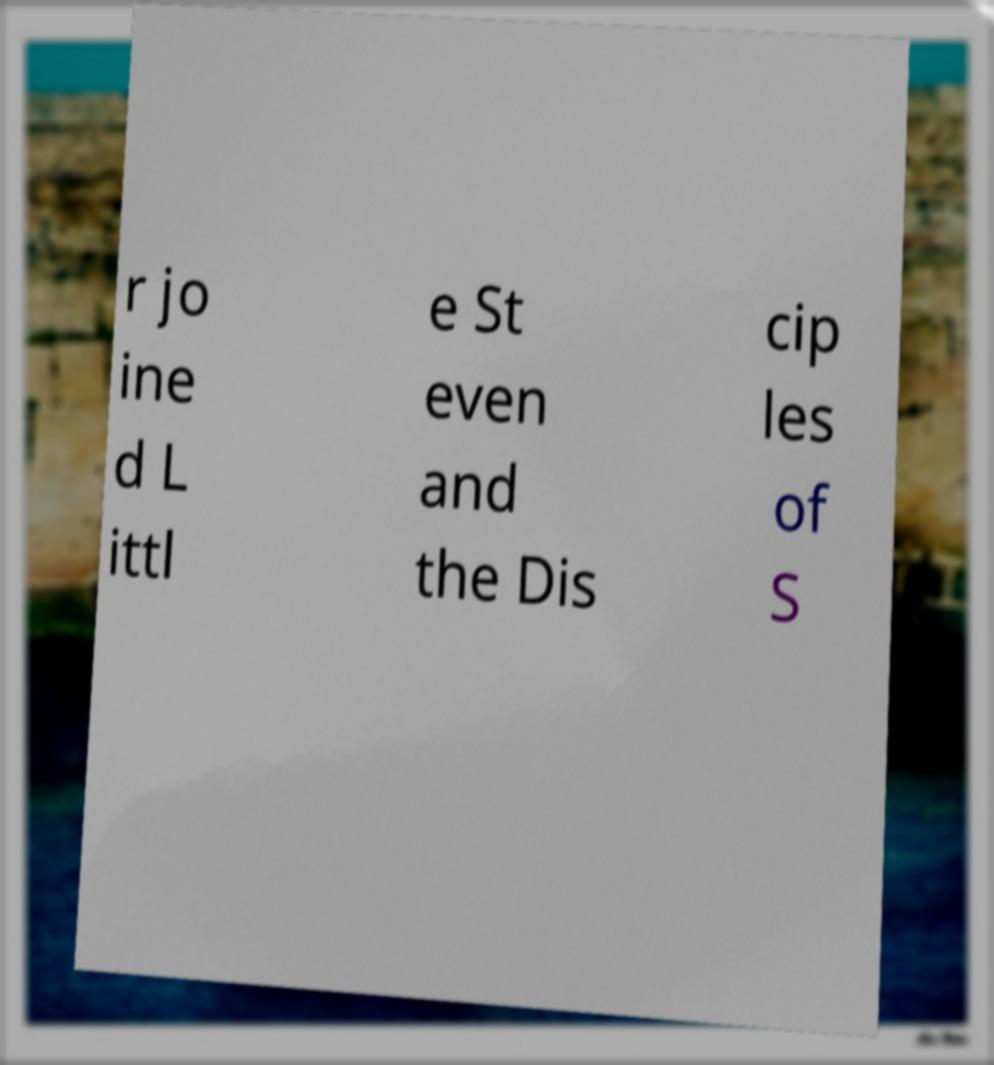What messages or text are displayed in this image? I need them in a readable, typed format. r jo ine d L ittl e St even and the Dis cip les of S 